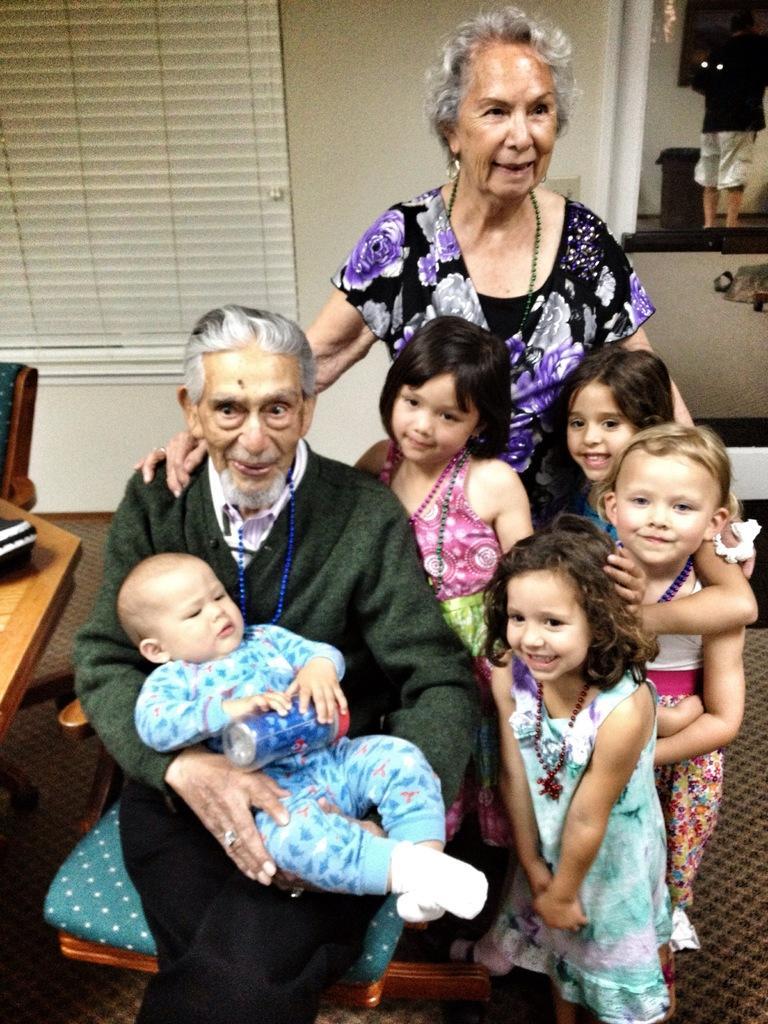Could you give a brief overview of what you see in this image? There are kids and woman standing and this man sitting and holding a baby,beside this man we can see an object on the table and chair. In the background we can see wall and mirror,through this mirror we can see a person. 